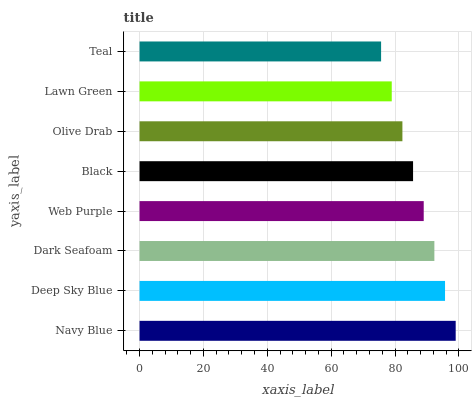Is Teal the minimum?
Answer yes or no. Yes. Is Navy Blue the maximum?
Answer yes or no. Yes. Is Deep Sky Blue the minimum?
Answer yes or no. No. Is Deep Sky Blue the maximum?
Answer yes or no. No. Is Navy Blue greater than Deep Sky Blue?
Answer yes or no. Yes. Is Deep Sky Blue less than Navy Blue?
Answer yes or no. Yes. Is Deep Sky Blue greater than Navy Blue?
Answer yes or no. No. Is Navy Blue less than Deep Sky Blue?
Answer yes or no. No. Is Web Purple the high median?
Answer yes or no. Yes. Is Black the low median?
Answer yes or no. Yes. Is Navy Blue the high median?
Answer yes or no. No. Is Dark Seafoam the low median?
Answer yes or no. No. 